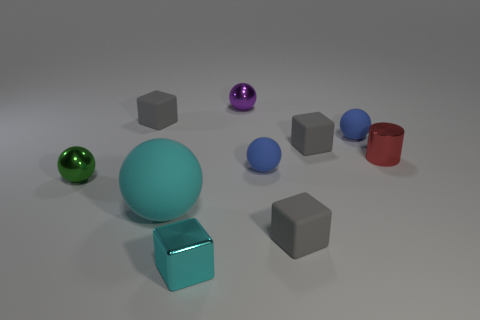There is another small shiny thing that is the same shape as the purple thing; what color is it?
Your answer should be compact. Green. How many cyan objects are spheres or tiny shiny balls?
Offer a terse response. 1. There is a sphere in front of the green metal thing that is on the left side of the metallic cube; what is it made of?
Your response must be concise. Rubber. Do the small purple shiny thing and the red shiny object have the same shape?
Offer a terse response. No. There is a metallic cube that is the same size as the red metal cylinder; what color is it?
Your answer should be compact. Cyan. Are there any big objects of the same color as the small cylinder?
Your answer should be compact. No. Are there any small green metal things?
Offer a very short reply. Yes. Is the gray thing that is to the left of the tiny shiny cube made of the same material as the large cyan object?
Ensure brevity in your answer.  Yes. What size is the object that is the same color as the metallic cube?
Ensure brevity in your answer.  Large. How many blue balls are the same size as the cyan metal block?
Keep it short and to the point. 2. 